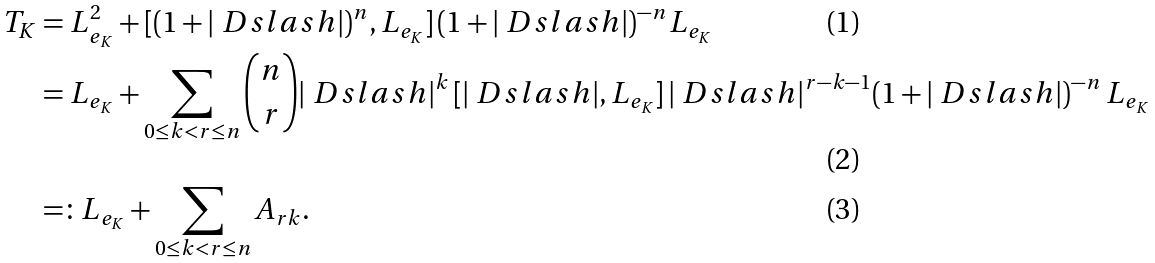Convert formula to latex. <formula><loc_0><loc_0><loc_500><loc_500>T _ { K } & = L _ { e _ { K } } ^ { 2 } + [ ( 1 + | \ D s l a s h | ) ^ { n } , L _ { e _ { K } } ] \, ( 1 + | \ D s l a s h | ) ^ { - n } L _ { e _ { K } } \\ & = L _ { e _ { K } } + \sum _ { 0 \leq k < r \leq n } \binom { n } { r } | \ D s l a s h | ^ { k } \, [ | \ D s l a s h | , L _ { e _ { K } } ] \, | \ D s l a s h | ^ { r - k - 1 } ( 1 + | \ D s l a s h | ) ^ { - n } \, L _ { e _ { K } } \\ & = \colon L _ { e _ { K } } + \sum _ { 0 \leq k < r \leq n } A _ { r k } .</formula> 